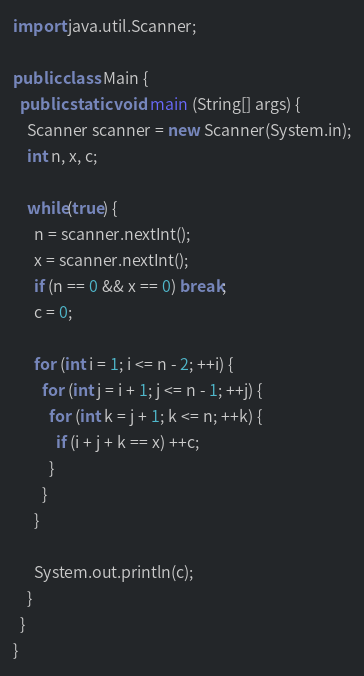Convert code to text. <code><loc_0><loc_0><loc_500><loc_500><_Java_>import java.util.Scanner;

public class Main {
  public static void main (String[] args) {
    Scanner scanner = new Scanner(System.in);
    int n, x, c;

    while(true) {
      n = scanner.nextInt();
      x = scanner.nextInt();
      if (n == 0 && x == 0) break;
      c = 0;

      for (int i = 1; i <= n - 2; ++i) {
        for (int j = i + 1; j <= n - 1; ++j) {
          for (int k = j + 1; k <= n; ++k) {
            if (i + j + k == x) ++c;
          }
        }
      }

      System.out.println(c);
    }
  }
}
</code> 